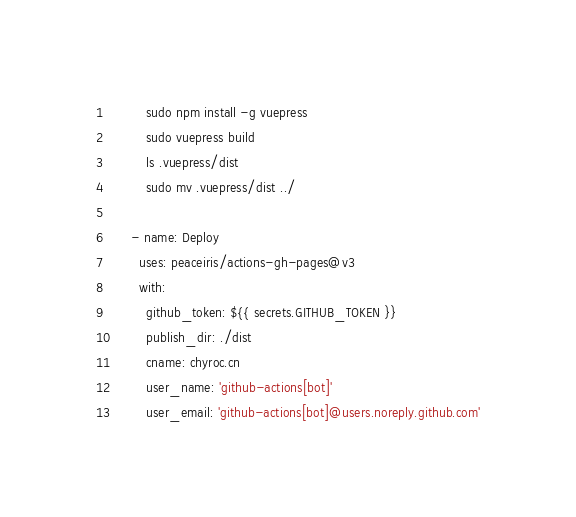Convert code to text. <code><loc_0><loc_0><loc_500><loc_500><_YAML_>          sudo npm install -g vuepress
          sudo vuepress build
          ls .vuepress/dist
          sudo mv .vuepress/dist ../

      - name: Deploy
        uses: peaceiris/actions-gh-pages@v3
        with:
          github_token: ${{ secrets.GITHUB_TOKEN }}
          publish_dir: ./dist
          cname: chyroc.cn
          user_name: 'github-actions[bot]'
          user_email: 'github-actions[bot]@users.noreply.github.com'
</code> 